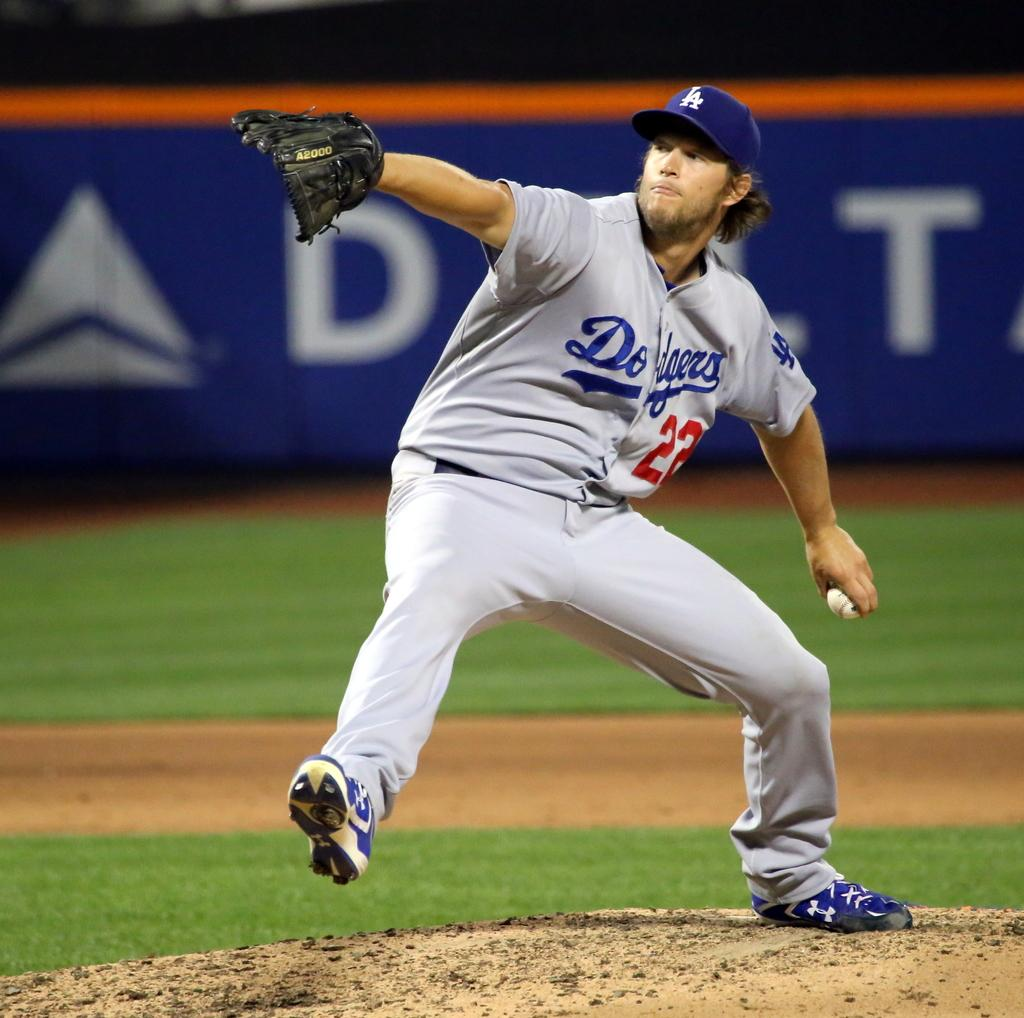Provide a one-sentence caption for the provided image. A baseball player with the number 22 on his shirt. 